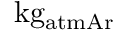<formula> <loc_0><loc_0><loc_500><loc_500>k g _ { a t m A r }</formula> 